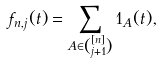Convert formula to latex. <formula><loc_0><loc_0><loc_500><loc_500>f _ { n , j } ( t ) = \sum _ { A \in \binom { [ n ] } { j + 1 } } 1 _ { A } ( t ) ,</formula> 